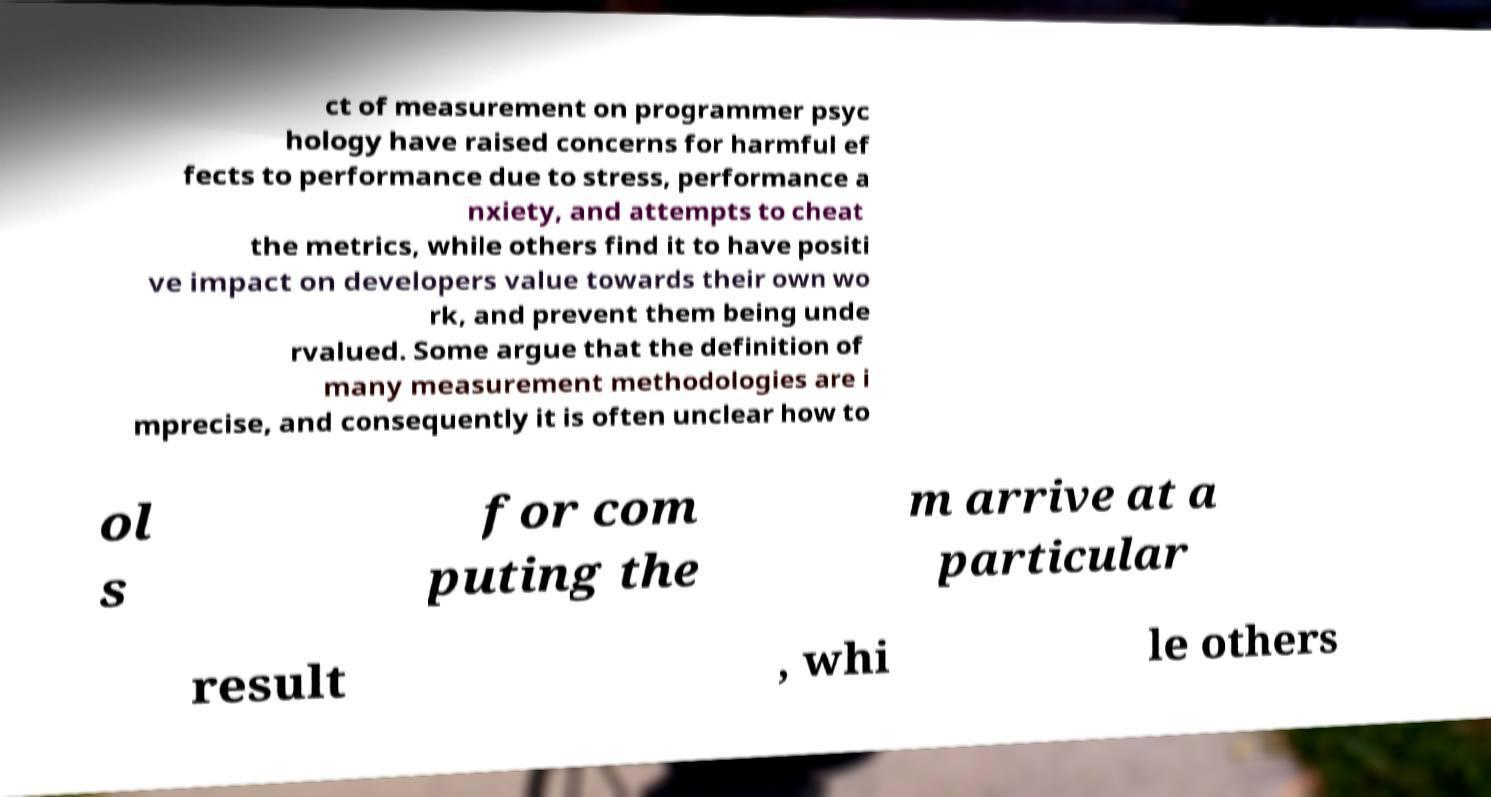Could you assist in decoding the text presented in this image and type it out clearly? ct of measurement on programmer psyc hology have raised concerns for harmful ef fects to performance due to stress, performance a nxiety, and attempts to cheat the metrics, while others find it to have positi ve impact on developers value towards their own wo rk, and prevent them being unde rvalued. Some argue that the definition of many measurement methodologies are i mprecise, and consequently it is often unclear how to ol s for com puting the m arrive at a particular result , whi le others 